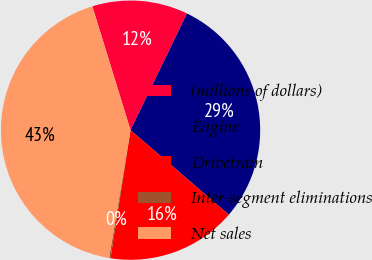<chart> <loc_0><loc_0><loc_500><loc_500><pie_chart><fcel>(millions of dollars)<fcel>Engine<fcel>Drivetrain<fcel>Inter-segment eliminations<fcel>Net sales<nl><fcel>11.93%<fcel>29.13%<fcel>16.17%<fcel>0.17%<fcel>42.59%<nl></chart> 